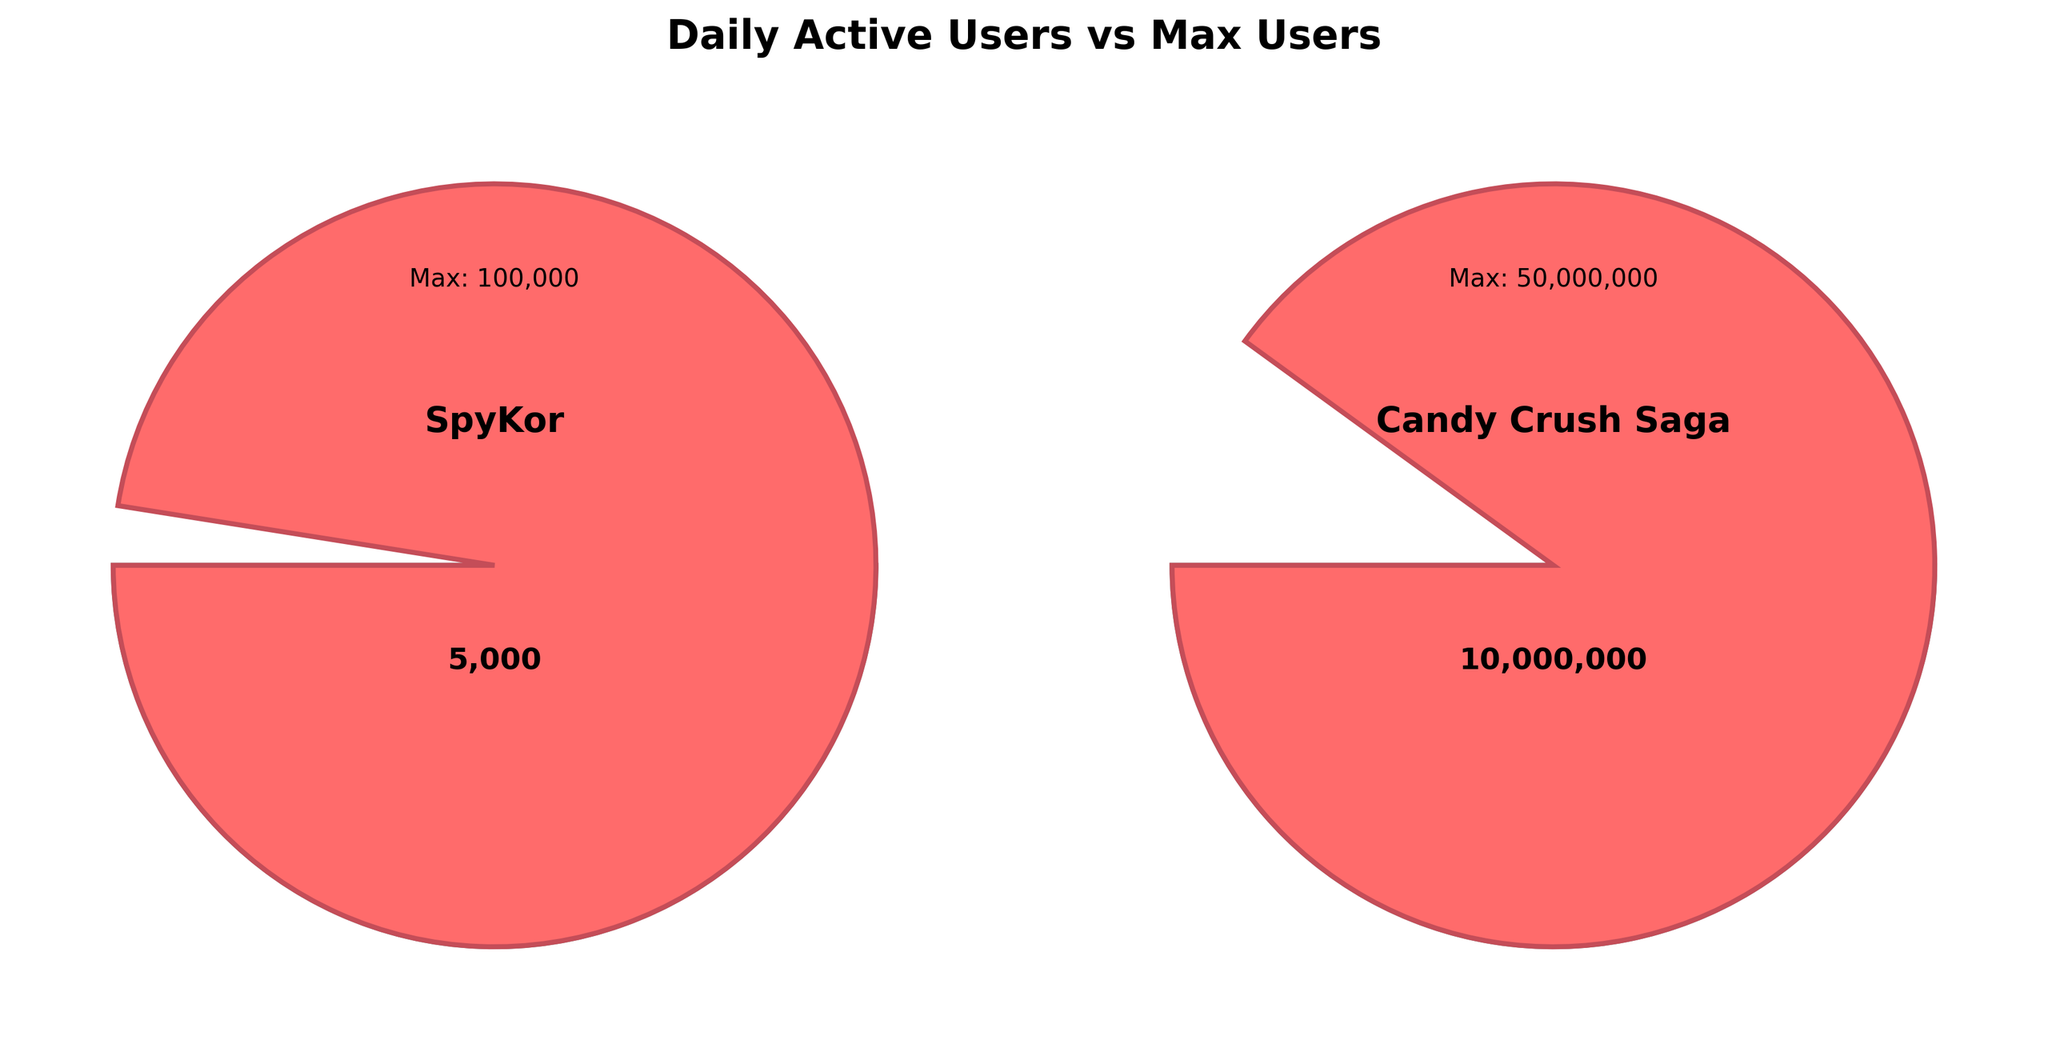What is the maximum number of users for SpyKor? The figure shows a "Max: 100,000" label for SpyKor, which indicates the maximum number of users for the game.
Answer: 100,000 What is the daily active user count for Candy Crush Saga? The gauge chart for Candy Crush Saga shows a label indicating "10,000,000" as the daily active users.
Answer: 10,000,000 Which game has a higher daily active user count? Comparing the daily active users from both charts, Candy Crush Saga has 10,000,000 while SpyKor has 5,000. Therefore, Candy Crush Saga has a higher daily active user count.
Answer: Candy Crush Saga What proportion of its maximum user count is SpyKor currently at? The gauge for SpyKor indicates 5,000 daily active users out of a maximum of 100,000. So, the proportion is 5,000 / 100,000, which is 0.05 or 5%.
Answer: 5% By what factor is the daily active user count of Candy Crush Saga greater than that of SpyKor? The daily active user count for Candy Crush Saga is 10,000,000 and for SpyKor, it is 5,000. The factor is 10,000,000 / 5,000 = 2000.
Answer: 2000 Which game has reached closer to its maximum user count in terms of percentage? SpyKor has 5% of its maximum users (5,000 out of 100,000), while Candy Crush Saga has 20% of its maximum users (10,000,000 out of 50,000,000). Therefore, Candy Crush Saga has reached closer to its maximum in percentage terms.
Answer: Candy Crush Saga What is the combined daily active user count of both games? Summing the daily active user counts of SpyKor (5,000) and Candy Crush Saga (10,000,000) gives 10,005,000.
Answer: 10,005,000 How much less is SpyKor's daily active user count compared to Candy Crush Saga's? The difference in daily active user count is 10,000,000 (Candy Crush Saga) - 5,000 (SpyKor) = 9,995,000.
Answer: 9,995,000 